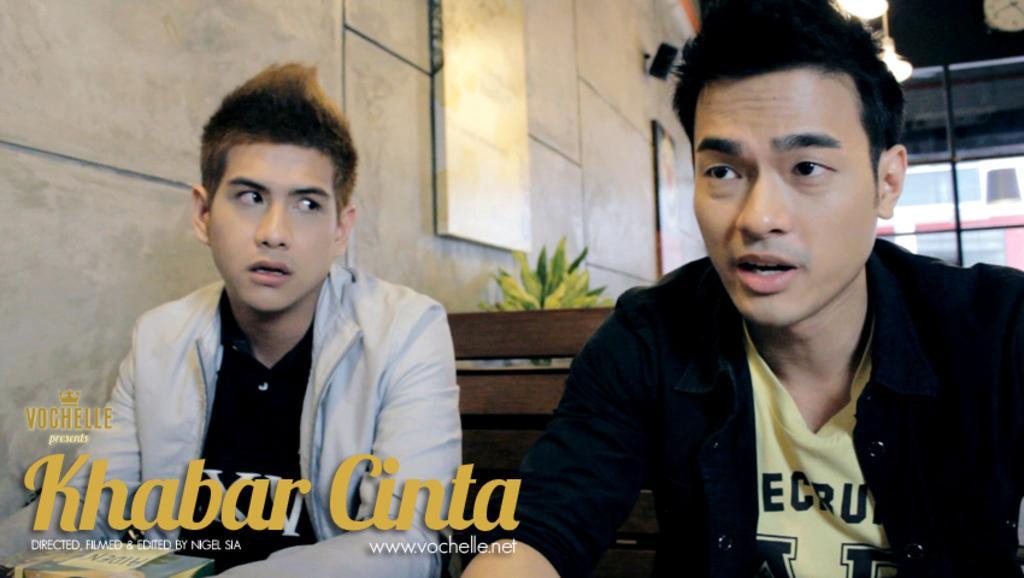Can you describe this image briefly? In this image in the foreground there are two persons who are sitting, and in front of them there are some books. In the background there is a plant, and on the wall there are some photo frames. On the right side there is a window, and at the top of the image there is a light and a clock, and at the bottom of the image there is some text. 